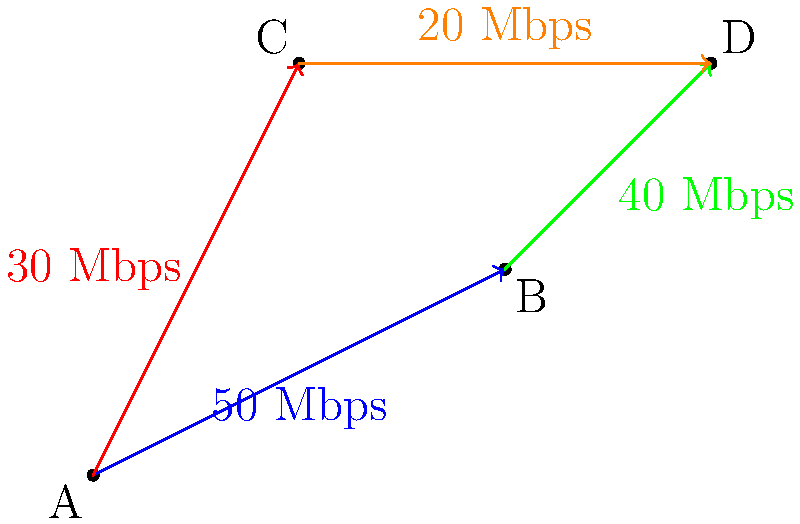In this software-defined network, data flows from node A to node D through two possible paths. If a new app requires a minimum of 45 Mbps to function properly, what is the maximum data flow that can be achieved for this app between nodes A and D? To solve this problem, we need to analyze the two possible paths from node A to node D:

1. Path 1: A → B → D
   - A to B: 50 Mbps
   - B to D: 40 Mbps
   - The maximum flow for this path is limited by the smallest value: 40 Mbps

2. Path 2: A → C → D
   - A to C: 30 Mbps
   - C to D: 20 Mbps
   - The maximum flow for this path is limited by the smallest value: 20 Mbps

3. Calculate the total maximum flow:
   - Total maximum flow = Flow of Path 1 + Flow of Path 2
   - Total maximum flow = 40 Mbps + 20 Mbps = 60 Mbps

4. Check if this meets the app's requirement:
   - The app requires a minimum of 45 Mbps
   - The total maximum flow (60 Mbps) exceeds this requirement

Therefore, the maximum data flow that can be achieved for this app between nodes A and D is 60 Mbps.
Answer: 60 Mbps 